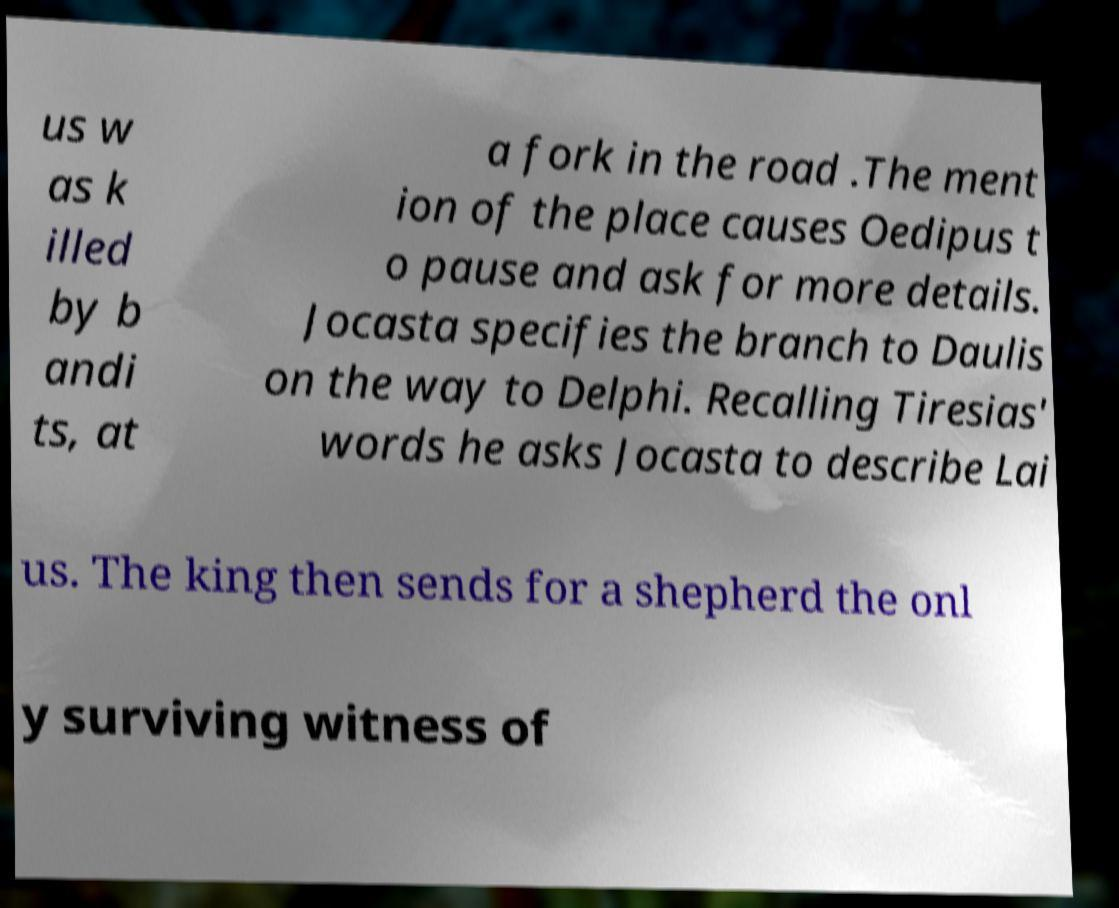Please identify and transcribe the text found in this image. us w as k illed by b andi ts, at a fork in the road .The ment ion of the place causes Oedipus t o pause and ask for more details. Jocasta specifies the branch to Daulis on the way to Delphi. Recalling Tiresias' words he asks Jocasta to describe Lai us. The king then sends for a shepherd the onl y surviving witness of 